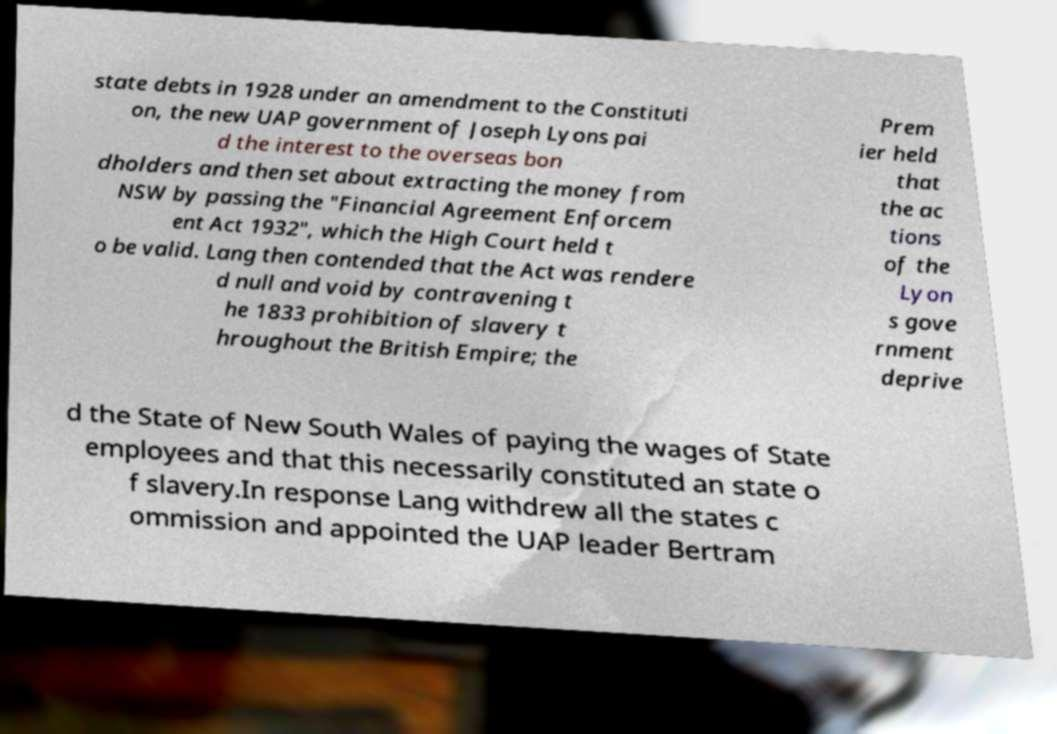What messages or text are displayed in this image? I need them in a readable, typed format. state debts in 1928 under an amendment to the Constituti on, the new UAP government of Joseph Lyons pai d the interest to the overseas bon dholders and then set about extracting the money from NSW by passing the "Financial Agreement Enforcem ent Act 1932", which the High Court held t o be valid. Lang then contended that the Act was rendere d null and void by contravening t he 1833 prohibition of slavery t hroughout the British Empire; the Prem ier held that the ac tions of the Lyon s gove rnment deprive d the State of New South Wales of paying the wages of State employees and that this necessarily constituted an state o f slavery.In response Lang withdrew all the states c ommission and appointed the UAP leader Bertram 